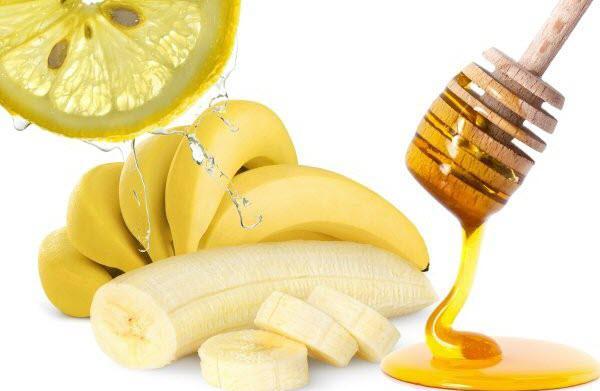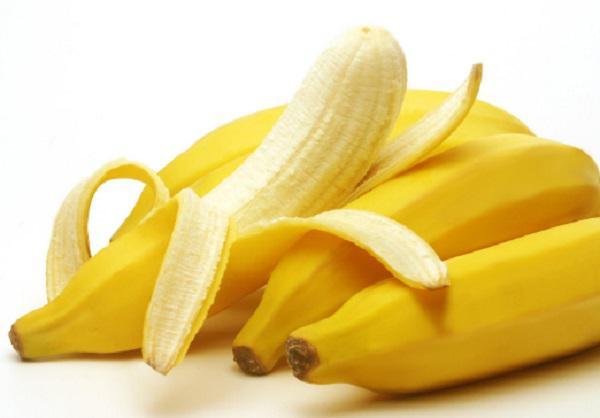The first image is the image on the left, the second image is the image on the right. For the images shown, is this caption "Atleast one photo in the pair is a single half peeled banana" true? Answer yes or no. No. 